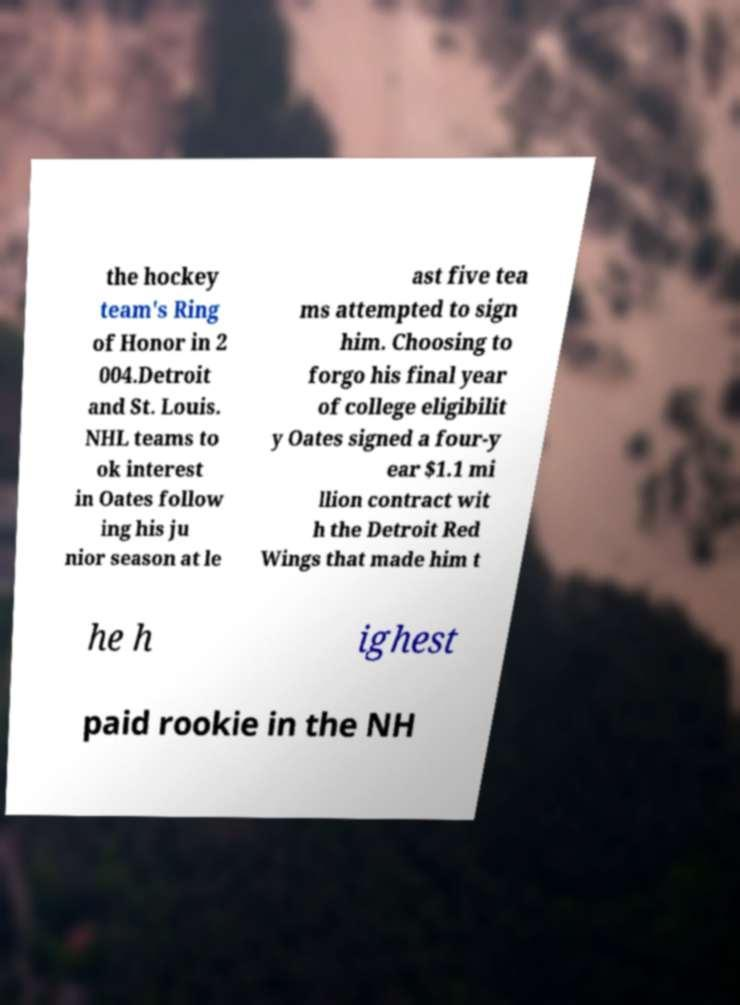Could you assist in decoding the text presented in this image and type it out clearly? the hockey team's Ring of Honor in 2 004.Detroit and St. Louis. NHL teams to ok interest in Oates follow ing his ju nior season at le ast five tea ms attempted to sign him. Choosing to forgo his final year of college eligibilit y Oates signed a four-y ear $1.1 mi llion contract wit h the Detroit Red Wings that made him t he h ighest paid rookie in the NH 